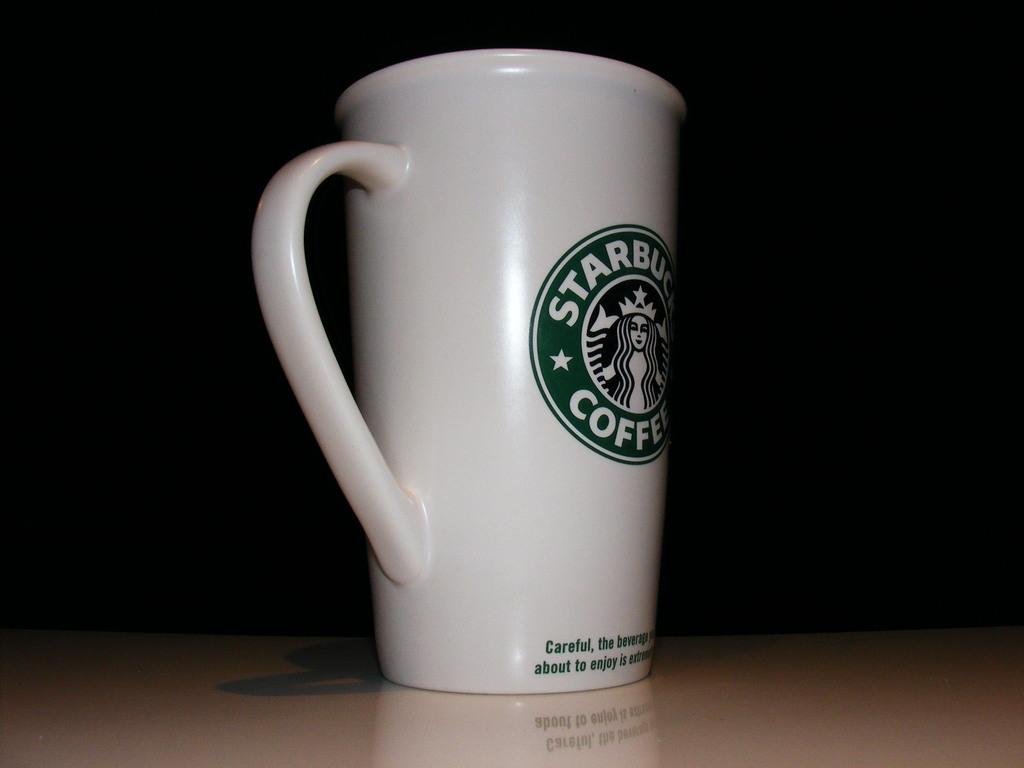What type of beverage was this mug made to hold?
Provide a succinct answer. Coffee. 